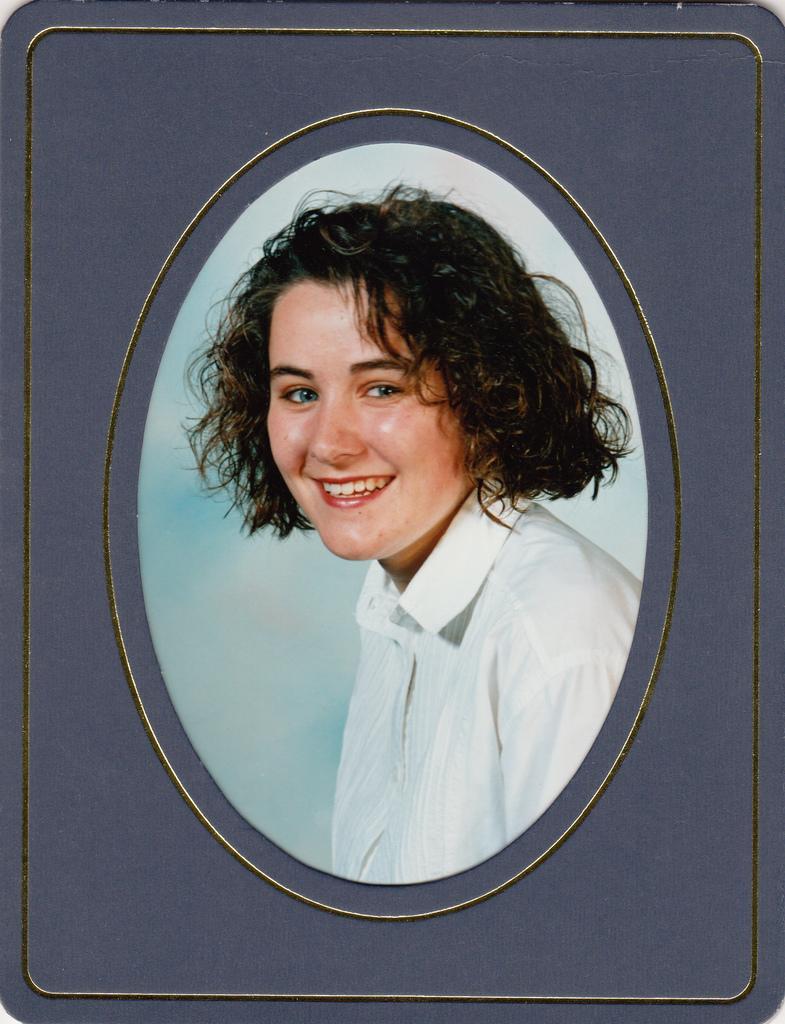In one or two sentences, can you explain what this image depicts? In this image we can see there is a girl in the photo frame. 